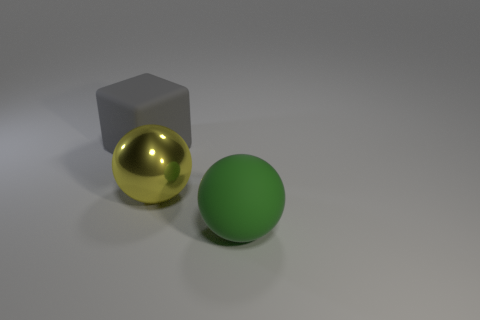There is a rubber thing in front of the gray thing; does it have the same shape as the gray matte object?
Ensure brevity in your answer.  No. Is the number of large green rubber things less than the number of large objects?
Your response must be concise. Yes. How many other big metallic objects are the same color as the big metal thing?
Provide a short and direct response. 0. Is the color of the big cube the same as the big matte object that is right of the gray matte object?
Your answer should be compact. No. Are there more large matte blocks than cyan metallic spheres?
Ensure brevity in your answer.  Yes. The other object that is the same shape as the yellow shiny object is what size?
Offer a terse response. Large. Are the large green thing and the object behind the yellow shiny ball made of the same material?
Offer a terse response. Yes. How many things are either large green metal cylinders or yellow spheres?
Offer a very short reply. 1. There is a matte object to the right of the gray cube; does it have the same size as the sphere to the left of the large green sphere?
Make the answer very short. Yes. How many spheres are large green matte objects or large yellow metal things?
Offer a very short reply. 2. 